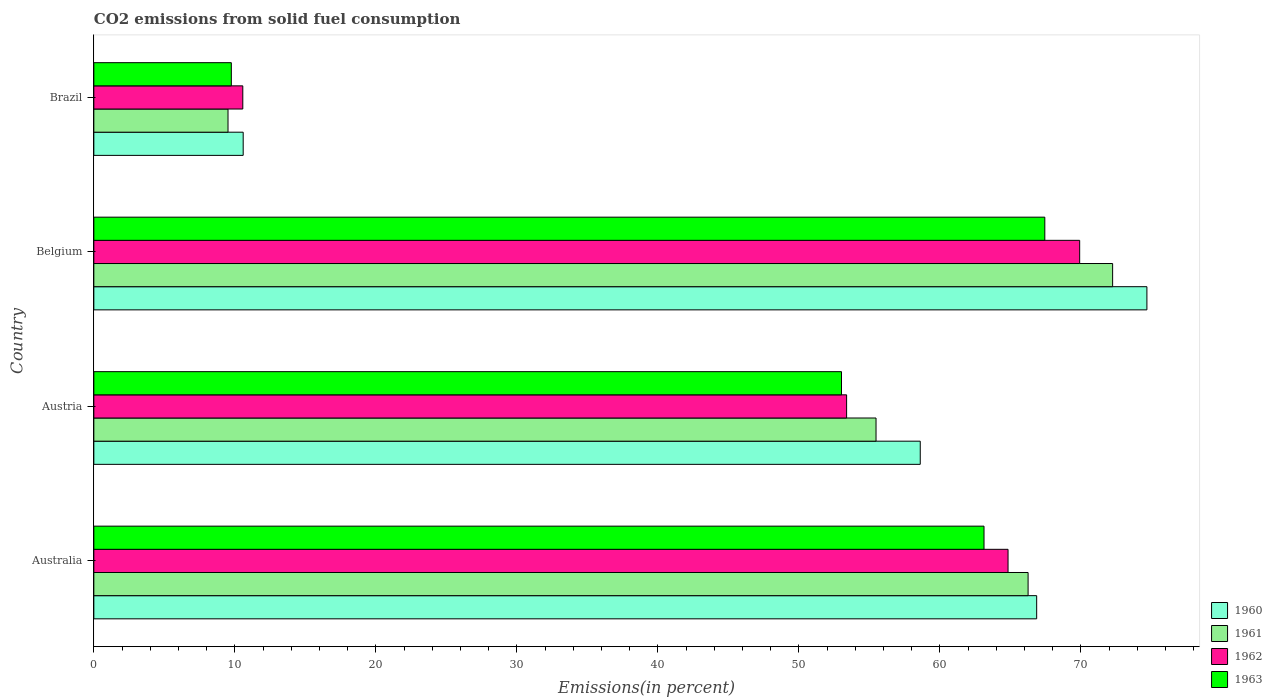How many different coloured bars are there?
Your response must be concise. 4. Are the number of bars per tick equal to the number of legend labels?
Offer a very short reply. Yes. Are the number of bars on each tick of the Y-axis equal?
Provide a succinct answer. Yes. How many bars are there on the 4th tick from the bottom?
Your answer should be very brief. 4. In how many cases, is the number of bars for a given country not equal to the number of legend labels?
Your answer should be compact. 0. What is the total CO2 emitted in 1960 in Australia?
Provide a succinct answer. 66.86. Across all countries, what is the maximum total CO2 emitted in 1962?
Keep it short and to the point. 69.91. Across all countries, what is the minimum total CO2 emitted in 1960?
Provide a short and direct response. 10.59. In which country was the total CO2 emitted in 1960 maximum?
Make the answer very short. Belgium. What is the total total CO2 emitted in 1960 in the graph?
Keep it short and to the point. 210.75. What is the difference between the total CO2 emitted in 1963 in Austria and that in Belgium?
Offer a terse response. -14.42. What is the difference between the total CO2 emitted in 1962 in Australia and the total CO2 emitted in 1960 in Belgium?
Make the answer very short. -9.85. What is the average total CO2 emitted in 1960 per country?
Give a very brief answer. 52.69. What is the difference between the total CO2 emitted in 1960 and total CO2 emitted in 1961 in Brazil?
Keep it short and to the point. 1.08. In how many countries, is the total CO2 emitted in 1960 greater than 74 %?
Your answer should be compact. 1. What is the ratio of the total CO2 emitted in 1961 in Australia to that in Belgium?
Provide a short and direct response. 0.92. Is the total CO2 emitted in 1962 in Austria less than that in Belgium?
Offer a very short reply. Yes. What is the difference between the highest and the second highest total CO2 emitted in 1960?
Ensure brevity in your answer.  7.82. What is the difference between the highest and the lowest total CO2 emitted in 1961?
Provide a succinct answer. 62.73. In how many countries, is the total CO2 emitted in 1963 greater than the average total CO2 emitted in 1963 taken over all countries?
Keep it short and to the point. 3. Is the sum of the total CO2 emitted in 1960 in Austria and Brazil greater than the maximum total CO2 emitted in 1962 across all countries?
Provide a succinct answer. No. Is it the case that in every country, the sum of the total CO2 emitted in 1963 and total CO2 emitted in 1960 is greater than the total CO2 emitted in 1961?
Give a very brief answer. Yes. How many countries are there in the graph?
Your response must be concise. 4. What is the difference between two consecutive major ticks on the X-axis?
Make the answer very short. 10. Are the values on the major ticks of X-axis written in scientific E-notation?
Offer a terse response. No. How are the legend labels stacked?
Your answer should be very brief. Vertical. What is the title of the graph?
Your answer should be very brief. CO2 emissions from solid fuel consumption. What is the label or title of the X-axis?
Provide a succinct answer. Emissions(in percent). What is the label or title of the Y-axis?
Give a very brief answer. Country. What is the Emissions(in percent) of 1960 in Australia?
Your answer should be compact. 66.86. What is the Emissions(in percent) in 1961 in Australia?
Offer a terse response. 66.26. What is the Emissions(in percent) in 1962 in Australia?
Offer a very short reply. 64.83. What is the Emissions(in percent) in 1963 in Australia?
Offer a terse response. 63.13. What is the Emissions(in percent) in 1960 in Austria?
Provide a short and direct response. 58.61. What is the Emissions(in percent) of 1961 in Austria?
Your answer should be very brief. 55.47. What is the Emissions(in percent) in 1962 in Austria?
Give a very brief answer. 53.39. What is the Emissions(in percent) in 1963 in Austria?
Keep it short and to the point. 53.02. What is the Emissions(in percent) of 1960 in Belgium?
Provide a succinct answer. 74.68. What is the Emissions(in percent) of 1961 in Belgium?
Provide a succinct answer. 72.25. What is the Emissions(in percent) in 1962 in Belgium?
Make the answer very short. 69.91. What is the Emissions(in percent) in 1963 in Belgium?
Your response must be concise. 67.44. What is the Emissions(in percent) of 1960 in Brazil?
Provide a short and direct response. 10.59. What is the Emissions(in percent) in 1961 in Brazil?
Your answer should be compact. 9.52. What is the Emissions(in percent) of 1962 in Brazil?
Offer a very short reply. 10.56. What is the Emissions(in percent) in 1963 in Brazil?
Your answer should be compact. 9.75. Across all countries, what is the maximum Emissions(in percent) in 1960?
Offer a very short reply. 74.68. Across all countries, what is the maximum Emissions(in percent) of 1961?
Your answer should be very brief. 72.25. Across all countries, what is the maximum Emissions(in percent) in 1962?
Keep it short and to the point. 69.91. Across all countries, what is the maximum Emissions(in percent) in 1963?
Keep it short and to the point. 67.44. Across all countries, what is the minimum Emissions(in percent) in 1960?
Provide a short and direct response. 10.59. Across all countries, what is the minimum Emissions(in percent) of 1961?
Offer a terse response. 9.52. Across all countries, what is the minimum Emissions(in percent) of 1962?
Offer a very short reply. 10.56. Across all countries, what is the minimum Emissions(in percent) in 1963?
Give a very brief answer. 9.75. What is the total Emissions(in percent) in 1960 in the graph?
Your answer should be compact. 210.75. What is the total Emissions(in percent) in 1961 in the graph?
Provide a succinct answer. 203.5. What is the total Emissions(in percent) in 1962 in the graph?
Offer a very short reply. 198.7. What is the total Emissions(in percent) in 1963 in the graph?
Make the answer very short. 193.35. What is the difference between the Emissions(in percent) of 1960 in Australia and that in Austria?
Provide a succinct answer. 8.26. What is the difference between the Emissions(in percent) in 1961 in Australia and that in Austria?
Keep it short and to the point. 10.78. What is the difference between the Emissions(in percent) in 1962 in Australia and that in Austria?
Offer a terse response. 11.45. What is the difference between the Emissions(in percent) of 1963 in Australia and that in Austria?
Give a very brief answer. 10.11. What is the difference between the Emissions(in percent) in 1960 in Australia and that in Belgium?
Keep it short and to the point. -7.82. What is the difference between the Emissions(in percent) in 1961 in Australia and that in Belgium?
Ensure brevity in your answer.  -5.99. What is the difference between the Emissions(in percent) of 1962 in Australia and that in Belgium?
Your answer should be very brief. -5.08. What is the difference between the Emissions(in percent) in 1963 in Australia and that in Belgium?
Your answer should be very brief. -4.31. What is the difference between the Emissions(in percent) of 1960 in Australia and that in Brazil?
Make the answer very short. 56.27. What is the difference between the Emissions(in percent) of 1961 in Australia and that in Brazil?
Offer a very short reply. 56.74. What is the difference between the Emissions(in percent) in 1962 in Australia and that in Brazil?
Offer a terse response. 54.27. What is the difference between the Emissions(in percent) of 1963 in Australia and that in Brazil?
Your answer should be very brief. 53.38. What is the difference between the Emissions(in percent) of 1960 in Austria and that in Belgium?
Your response must be concise. -16.07. What is the difference between the Emissions(in percent) of 1961 in Austria and that in Belgium?
Give a very brief answer. -16.78. What is the difference between the Emissions(in percent) in 1962 in Austria and that in Belgium?
Give a very brief answer. -16.53. What is the difference between the Emissions(in percent) in 1963 in Austria and that in Belgium?
Keep it short and to the point. -14.42. What is the difference between the Emissions(in percent) of 1960 in Austria and that in Brazil?
Your answer should be very brief. 48.02. What is the difference between the Emissions(in percent) of 1961 in Austria and that in Brazil?
Provide a short and direct response. 45.96. What is the difference between the Emissions(in percent) in 1962 in Austria and that in Brazil?
Make the answer very short. 42.82. What is the difference between the Emissions(in percent) of 1963 in Austria and that in Brazil?
Ensure brevity in your answer.  43.27. What is the difference between the Emissions(in percent) in 1960 in Belgium and that in Brazil?
Offer a very short reply. 64.09. What is the difference between the Emissions(in percent) in 1961 in Belgium and that in Brazil?
Your response must be concise. 62.73. What is the difference between the Emissions(in percent) in 1962 in Belgium and that in Brazil?
Keep it short and to the point. 59.35. What is the difference between the Emissions(in percent) of 1963 in Belgium and that in Brazil?
Make the answer very short. 57.69. What is the difference between the Emissions(in percent) in 1960 in Australia and the Emissions(in percent) in 1961 in Austria?
Your answer should be very brief. 11.39. What is the difference between the Emissions(in percent) of 1960 in Australia and the Emissions(in percent) of 1962 in Austria?
Provide a succinct answer. 13.48. What is the difference between the Emissions(in percent) of 1960 in Australia and the Emissions(in percent) of 1963 in Austria?
Your answer should be compact. 13.84. What is the difference between the Emissions(in percent) of 1961 in Australia and the Emissions(in percent) of 1962 in Austria?
Your answer should be compact. 12.87. What is the difference between the Emissions(in percent) in 1961 in Australia and the Emissions(in percent) in 1963 in Austria?
Make the answer very short. 13.23. What is the difference between the Emissions(in percent) in 1962 in Australia and the Emissions(in percent) in 1963 in Austria?
Provide a succinct answer. 11.81. What is the difference between the Emissions(in percent) of 1960 in Australia and the Emissions(in percent) of 1961 in Belgium?
Offer a very short reply. -5.39. What is the difference between the Emissions(in percent) of 1960 in Australia and the Emissions(in percent) of 1962 in Belgium?
Make the answer very short. -3.05. What is the difference between the Emissions(in percent) of 1960 in Australia and the Emissions(in percent) of 1963 in Belgium?
Provide a succinct answer. -0.58. What is the difference between the Emissions(in percent) in 1961 in Australia and the Emissions(in percent) in 1962 in Belgium?
Offer a terse response. -3.66. What is the difference between the Emissions(in percent) of 1961 in Australia and the Emissions(in percent) of 1963 in Belgium?
Your answer should be very brief. -1.19. What is the difference between the Emissions(in percent) in 1962 in Australia and the Emissions(in percent) in 1963 in Belgium?
Provide a short and direct response. -2.61. What is the difference between the Emissions(in percent) of 1960 in Australia and the Emissions(in percent) of 1961 in Brazil?
Your answer should be compact. 57.35. What is the difference between the Emissions(in percent) of 1960 in Australia and the Emissions(in percent) of 1962 in Brazil?
Your response must be concise. 56.3. What is the difference between the Emissions(in percent) in 1960 in Australia and the Emissions(in percent) in 1963 in Brazil?
Provide a succinct answer. 57.11. What is the difference between the Emissions(in percent) in 1961 in Australia and the Emissions(in percent) in 1962 in Brazil?
Provide a succinct answer. 55.69. What is the difference between the Emissions(in percent) in 1961 in Australia and the Emissions(in percent) in 1963 in Brazil?
Provide a short and direct response. 56.51. What is the difference between the Emissions(in percent) of 1962 in Australia and the Emissions(in percent) of 1963 in Brazil?
Offer a terse response. 55.08. What is the difference between the Emissions(in percent) in 1960 in Austria and the Emissions(in percent) in 1961 in Belgium?
Provide a succinct answer. -13.64. What is the difference between the Emissions(in percent) in 1960 in Austria and the Emissions(in percent) in 1962 in Belgium?
Keep it short and to the point. -11.31. What is the difference between the Emissions(in percent) in 1960 in Austria and the Emissions(in percent) in 1963 in Belgium?
Your answer should be compact. -8.83. What is the difference between the Emissions(in percent) in 1961 in Austria and the Emissions(in percent) in 1962 in Belgium?
Provide a succinct answer. -14.44. What is the difference between the Emissions(in percent) of 1961 in Austria and the Emissions(in percent) of 1963 in Belgium?
Your answer should be compact. -11.97. What is the difference between the Emissions(in percent) of 1962 in Austria and the Emissions(in percent) of 1963 in Belgium?
Offer a terse response. -14.06. What is the difference between the Emissions(in percent) of 1960 in Austria and the Emissions(in percent) of 1961 in Brazil?
Keep it short and to the point. 49.09. What is the difference between the Emissions(in percent) in 1960 in Austria and the Emissions(in percent) in 1962 in Brazil?
Offer a very short reply. 48.04. What is the difference between the Emissions(in percent) of 1960 in Austria and the Emissions(in percent) of 1963 in Brazil?
Your answer should be very brief. 48.86. What is the difference between the Emissions(in percent) in 1961 in Austria and the Emissions(in percent) in 1962 in Brazil?
Give a very brief answer. 44.91. What is the difference between the Emissions(in percent) of 1961 in Austria and the Emissions(in percent) of 1963 in Brazil?
Your answer should be compact. 45.72. What is the difference between the Emissions(in percent) of 1962 in Austria and the Emissions(in percent) of 1963 in Brazil?
Keep it short and to the point. 43.63. What is the difference between the Emissions(in percent) in 1960 in Belgium and the Emissions(in percent) in 1961 in Brazil?
Give a very brief answer. 65.16. What is the difference between the Emissions(in percent) of 1960 in Belgium and the Emissions(in percent) of 1962 in Brazil?
Keep it short and to the point. 64.12. What is the difference between the Emissions(in percent) of 1960 in Belgium and the Emissions(in percent) of 1963 in Brazil?
Offer a terse response. 64.93. What is the difference between the Emissions(in percent) of 1961 in Belgium and the Emissions(in percent) of 1962 in Brazil?
Give a very brief answer. 61.69. What is the difference between the Emissions(in percent) of 1961 in Belgium and the Emissions(in percent) of 1963 in Brazil?
Your answer should be very brief. 62.5. What is the difference between the Emissions(in percent) of 1962 in Belgium and the Emissions(in percent) of 1963 in Brazil?
Your response must be concise. 60.16. What is the average Emissions(in percent) in 1960 per country?
Offer a terse response. 52.69. What is the average Emissions(in percent) in 1961 per country?
Your answer should be very brief. 50.87. What is the average Emissions(in percent) in 1962 per country?
Keep it short and to the point. 49.67. What is the average Emissions(in percent) of 1963 per country?
Your answer should be compact. 48.34. What is the difference between the Emissions(in percent) in 1960 and Emissions(in percent) in 1961 in Australia?
Make the answer very short. 0.61. What is the difference between the Emissions(in percent) of 1960 and Emissions(in percent) of 1962 in Australia?
Your answer should be compact. 2.03. What is the difference between the Emissions(in percent) in 1960 and Emissions(in percent) in 1963 in Australia?
Offer a terse response. 3.73. What is the difference between the Emissions(in percent) in 1961 and Emissions(in percent) in 1962 in Australia?
Make the answer very short. 1.42. What is the difference between the Emissions(in percent) in 1961 and Emissions(in percent) in 1963 in Australia?
Your answer should be very brief. 3.13. What is the difference between the Emissions(in percent) in 1962 and Emissions(in percent) in 1963 in Australia?
Provide a succinct answer. 1.7. What is the difference between the Emissions(in percent) in 1960 and Emissions(in percent) in 1961 in Austria?
Provide a short and direct response. 3.14. What is the difference between the Emissions(in percent) of 1960 and Emissions(in percent) of 1962 in Austria?
Provide a succinct answer. 5.22. What is the difference between the Emissions(in percent) of 1960 and Emissions(in percent) of 1963 in Austria?
Provide a short and direct response. 5.58. What is the difference between the Emissions(in percent) in 1961 and Emissions(in percent) in 1962 in Austria?
Provide a short and direct response. 2.09. What is the difference between the Emissions(in percent) in 1961 and Emissions(in percent) in 1963 in Austria?
Provide a short and direct response. 2.45. What is the difference between the Emissions(in percent) of 1962 and Emissions(in percent) of 1963 in Austria?
Offer a terse response. 0.36. What is the difference between the Emissions(in percent) in 1960 and Emissions(in percent) in 1961 in Belgium?
Offer a very short reply. 2.43. What is the difference between the Emissions(in percent) in 1960 and Emissions(in percent) in 1962 in Belgium?
Your response must be concise. 4.77. What is the difference between the Emissions(in percent) of 1960 and Emissions(in percent) of 1963 in Belgium?
Ensure brevity in your answer.  7.24. What is the difference between the Emissions(in percent) in 1961 and Emissions(in percent) in 1962 in Belgium?
Keep it short and to the point. 2.34. What is the difference between the Emissions(in percent) of 1961 and Emissions(in percent) of 1963 in Belgium?
Make the answer very short. 4.81. What is the difference between the Emissions(in percent) in 1962 and Emissions(in percent) in 1963 in Belgium?
Your answer should be compact. 2.47. What is the difference between the Emissions(in percent) in 1960 and Emissions(in percent) in 1961 in Brazil?
Offer a very short reply. 1.08. What is the difference between the Emissions(in percent) in 1960 and Emissions(in percent) in 1962 in Brazil?
Your response must be concise. 0.03. What is the difference between the Emissions(in percent) of 1960 and Emissions(in percent) of 1963 in Brazil?
Ensure brevity in your answer.  0.84. What is the difference between the Emissions(in percent) of 1961 and Emissions(in percent) of 1962 in Brazil?
Ensure brevity in your answer.  -1.05. What is the difference between the Emissions(in percent) of 1961 and Emissions(in percent) of 1963 in Brazil?
Offer a very short reply. -0.23. What is the difference between the Emissions(in percent) in 1962 and Emissions(in percent) in 1963 in Brazil?
Make the answer very short. 0.81. What is the ratio of the Emissions(in percent) of 1960 in Australia to that in Austria?
Your answer should be very brief. 1.14. What is the ratio of the Emissions(in percent) in 1961 in Australia to that in Austria?
Offer a very short reply. 1.19. What is the ratio of the Emissions(in percent) in 1962 in Australia to that in Austria?
Your answer should be very brief. 1.21. What is the ratio of the Emissions(in percent) of 1963 in Australia to that in Austria?
Provide a succinct answer. 1.19. What is the ratio of the Emissions(in percent) in 1960 in Australia to that in Belgium?
Offer a very short reply. 0.9. What is the ratio of the Emissions(in percent) of 1961 in Australia to that in Belgium?
Your answer should be very brief. 0.92. What is the ratio of the Emissions(in percent) of 1962 in Australia to that in Belgium?
Your response must be concise. 0.93. What is the ratio of the Emissions(in percent) of 1963 in Australia to that in Belgium?
Provide a short and direct response. 0.94. What is the ratio of the Emissions(in percent) of 1960 in Australia to that in Brazil?
Your answer should be very brief. 6.31. What is the ratio of the Emissions(in percent) in 1961 in Australia to that in Brazil?
Offer a very short reply. 6.96. What is the ratio of the Emissions(in percent) of 1962 in Australia to that in Brazil?
Your response must be concise. 6.14. What is the ratio of the Emissions(in percent) of 1963 in Australia to that in Brazil?
Your answer should be compact. 6.47. What is the ratio of the Emissions(in percent) of 1960 in Austria to that in Belgium?
Give a very brief answer. 0.78. What is the ratio of the Emissions(in percent) in 1961 in Austria to that in Belgium?
Keep it short and to the point. 0.77. What is the ratio of the Emissions(in percent) of 1962 in Austria to that in Belgium?
Keep it short and to the point. 0.76. What is the ratio of the Emissions(in percent) of 1963 in Austria to that in Belgium?
Ensure brevity in your answer.  0.79. What is the ratio of the Emissions(in percent) in 1960 in Austria to that in Brazil?
Keep it short and to the point. 5.53. What is the ratio of the Emissions(in percent) of 1961 in Austria to that in Brazil?
Keep it short and to the point. 5.83. What is the ratio of the Emissions(in percent) in 1962 in Austria to that in Brazil?
Offer a very short reply. 5.05. What is the ratio of the Emissions(in percent) in 1963 in Austria to that in Brazil?
Ensure brevity in your answer.  5.44. What is the ratio of the Emissions(in percent) in 1960 in Belgium to that in Brazil?
Make the answer very short. 7.05. What is the ratio of the Emissions(in percent) in 1961 in Belgium to that in Brazil?
Make the answer very short. 7.59. What is the ratio of the Emissions(in percent) in 1962 in Belgium to that in Brazil?
Keep it short and to the point. 6.62. What is the ratio of the Emissions(in percent) in 1963 in Belgium to that in Brazil?
Offer a terse response. 6.92. What is the difference between the highest and the second highest Emissions(in percent) of 1960?
Ensure brevity in your answer.  7.82. What is the difference between the highest and the second highest Emissions(in percent) in 1961?
Provide a succinct answer. 5.99. What is the difference between the highest and the second highest Emissions(in percent) in 1962?
Provide a succinct answer. 5.08. What is the difference between the highest and the second highest Emissions(in percent) in 1963?
Keep it short and to the point. 4.31. What is the difference between the highest and the lowest Emissions(in percent) in 1960?
Ensure brevity in your answer.  64.09. What is the difference between the highest and the lowest Emissions(in percent) in 1961?
Provide a succinct answer. 62.73. What is the difference between the highest and the lowest Emissions(in percent) in 1962?
Ensure brevity in your answer.  59.35. What is the difference between the highest and the lowest Emissions(in percent) in 1963?
Keep it short and to the point. 57.69. 